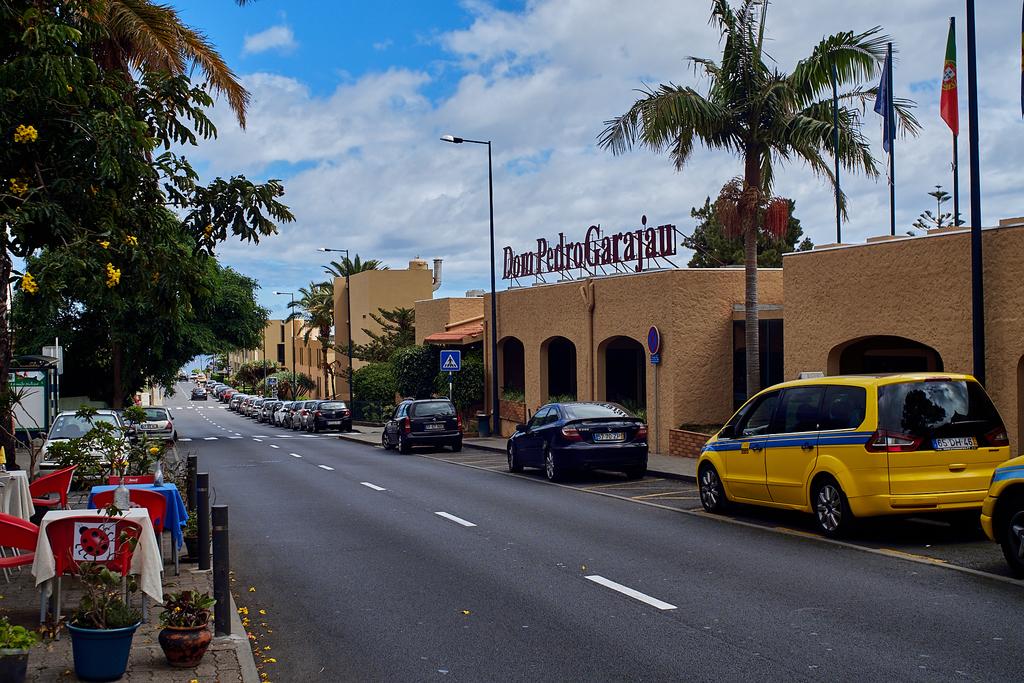What is the name of this restaurant?
Offer a terse response. Dom pedro garajau. What is the tag number of the yellow van?
Ensure brevity in your answer.  Unanswerable. 